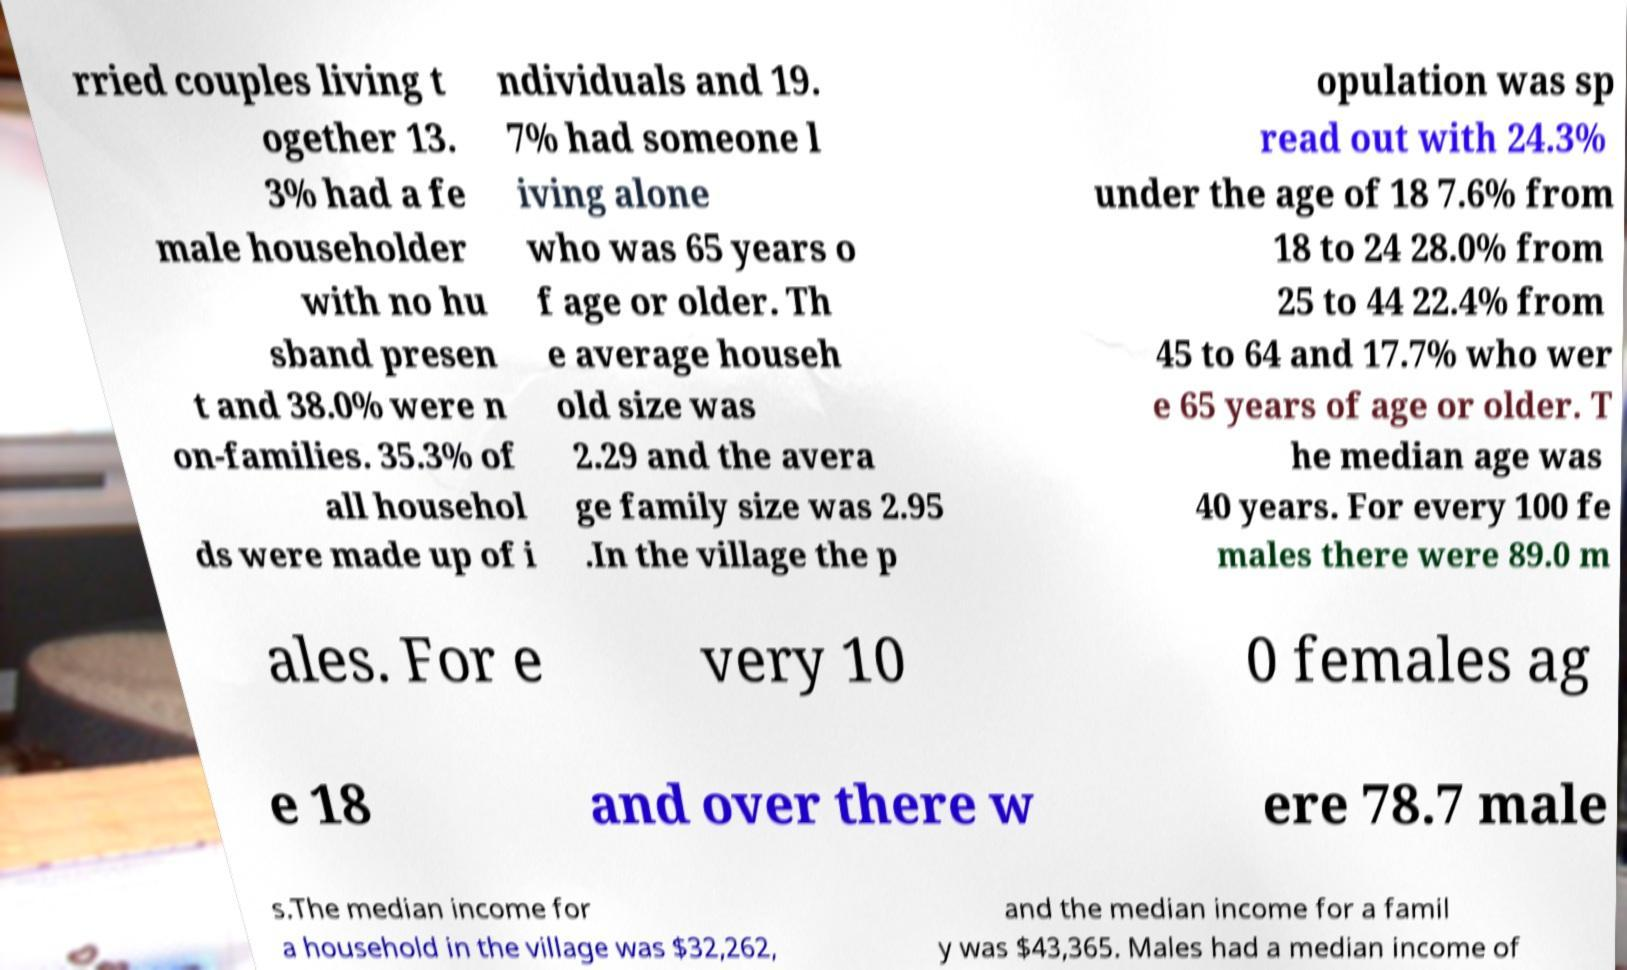What messages or text are displayed in this image? I need them in a readable, typed format. rried couples living t ogether 13. 3% had a fe male householder with no hu sband presen t and 38.0% were n on-families. 35.3% of all househol ds were made up of i ndividuals and 19. 7% had someone l iving alone who was 65 years o f age or older. Th e average househ old size was 2.29 and the avera ge family size was 2.95 .In the village the p opulation was sp read out with 24.3% under the age of 18 7.6% from 18 to 24 28.0% from 25 to 44 22.4% from 45 to 64 and 17.7% who wer e 65 years of age or older. T he median age was 40 years. For every 100 fe males there were 89.0 m ales. For e very 10 0 females ag e 18 and over there w ere 78.7 male s.The median income for a household in the village was $32,262, and the median income for a famil y was $43,365. Males had a median income of 